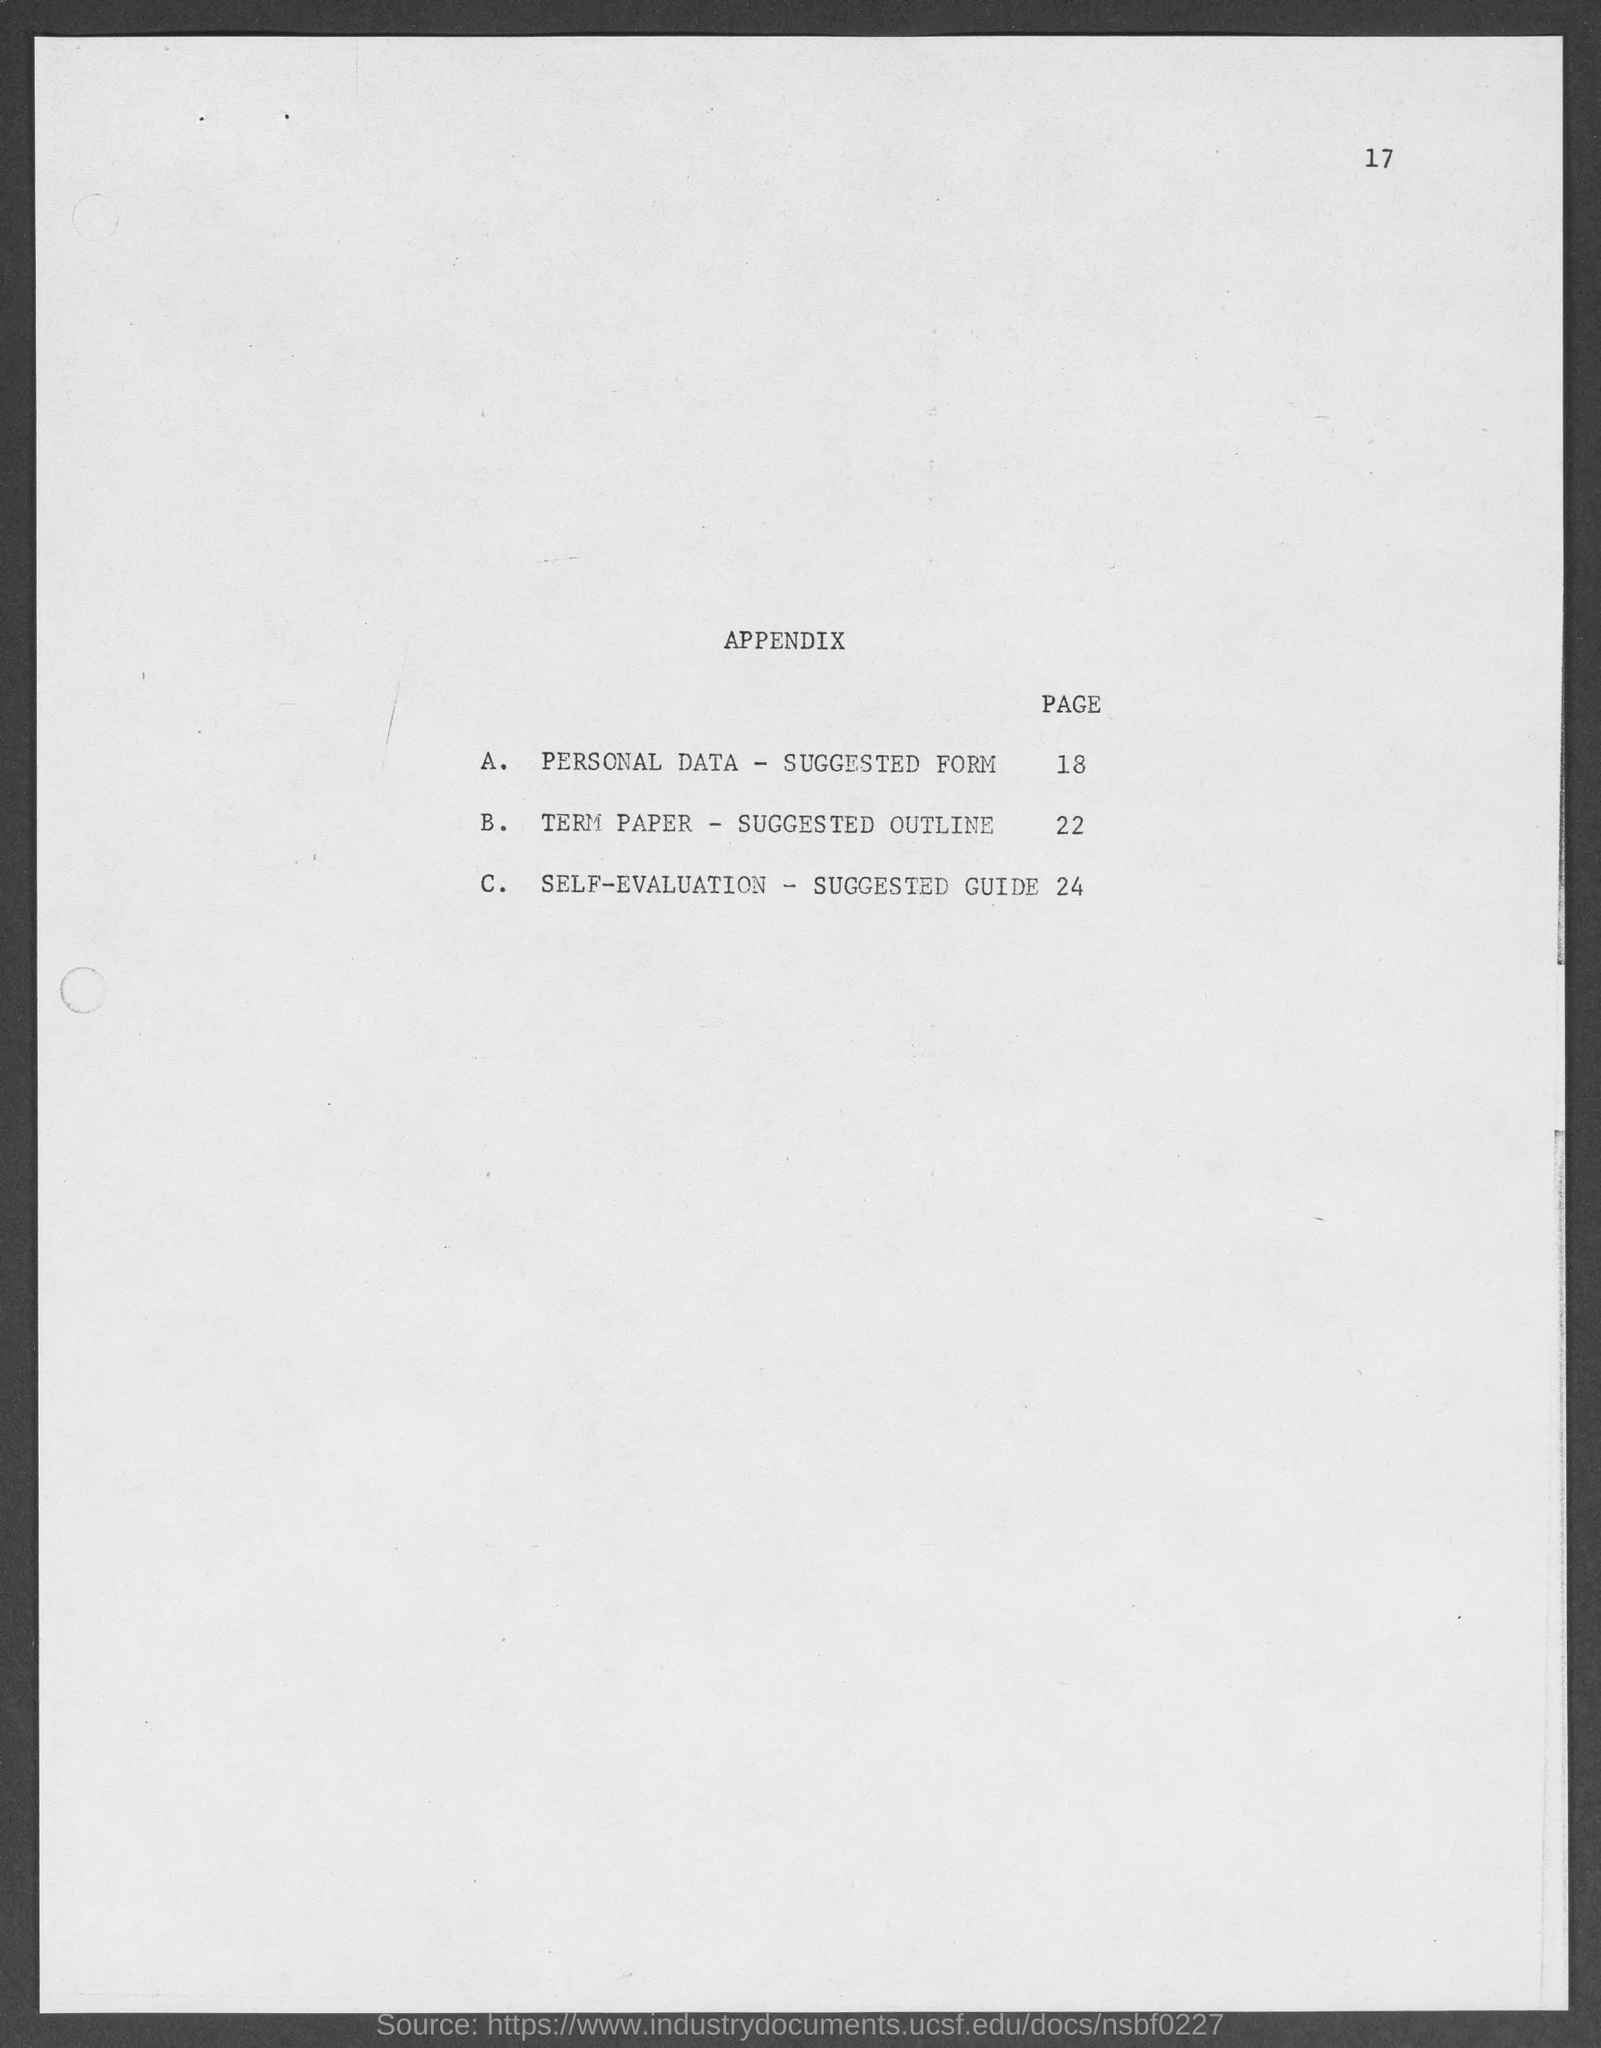Specify some key components in this picture. The page number at the top of the page is 17. 